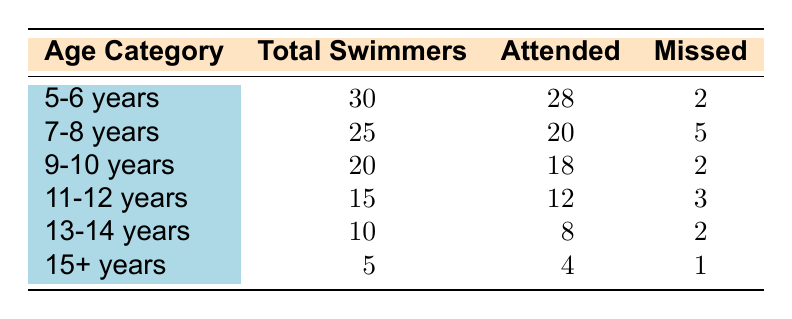What is the total number of swimmers in the 9-10 years age category? The table states that the total swimmers in the 9-10 years age category is listed under the "Total Swimmers" column, which shows 20.
Answer: 20 How many swimmers in the 7-8 years category missed their lessons? In the 7-8 years category, the number of swimmers who missed their lessons is directly provided in the "Missed" column, which indicates 5.
Answer: 5 Which age category has the highest percentage of swimmers who attended lessons? To find the highest percentage, we calculate attendance rates for all age categories: 5-6 years: 28/30 = 93.3%, 7-8 years: 20/25 = 80%, 9-10 years: 18/20 = 90%, 11-12 years: 12/15 = 80%, 13-14 years: 8/10 = 80%, 15+ years: 4/5 = 80%. The highest percentage is for the 5-6 years category at 93.3%.
Answer: 5-6 years How many swimmers from all age categories combined attended lessons? We add the "Attended" values from all age categories: 28 + 20 + 18 + 12 + 8 + 4 = 90. Thus, the total number of swimmers who attended lessons is 90.
Answer: 90 Is there an age category where all swimmers attended lessons? We check the "Attended" and "Total Swimmers" values for each age category. The 15+ years category has 5 total swimmers and 4 attended, meaning not all attended. The same is true for all categories checked. Thus, no age category has all swimmers attending lessons.
Answer: No What is the difference in the number of swimmers who missed lessons between the 11-12 years and 5-6 years categories? The 11-12 years category has 3 missed lessons and the 5-6 years category has 2 missed lessons. The difference is 3 - 2 = 1.
Answer: 1 What is the average number of missed lessons across all age categories? To find the average, we sum the missed lessons: 2 + 5 + 2 + 3 + 2 + 1 = 15. There are 6 age categories, so the average is 15/6 = 2.5.
Answer: 2.5 How many total swimmers are there in the age category with the least number of total swimmers? The age category with the least total swimmers is the 15+ years category with 5 total swimmers indicated in the "Total Swimmers" column.
Answer: 5 Which age category had fewer swimmers missed lessons between 9-10 years and 15+ years? The 9-10 years category missed 2 lessons, while the 15+ years category missed 1 lesson. Since 1 < 2, the 15+ years category had fewer missed.
Answer: 15+ years 